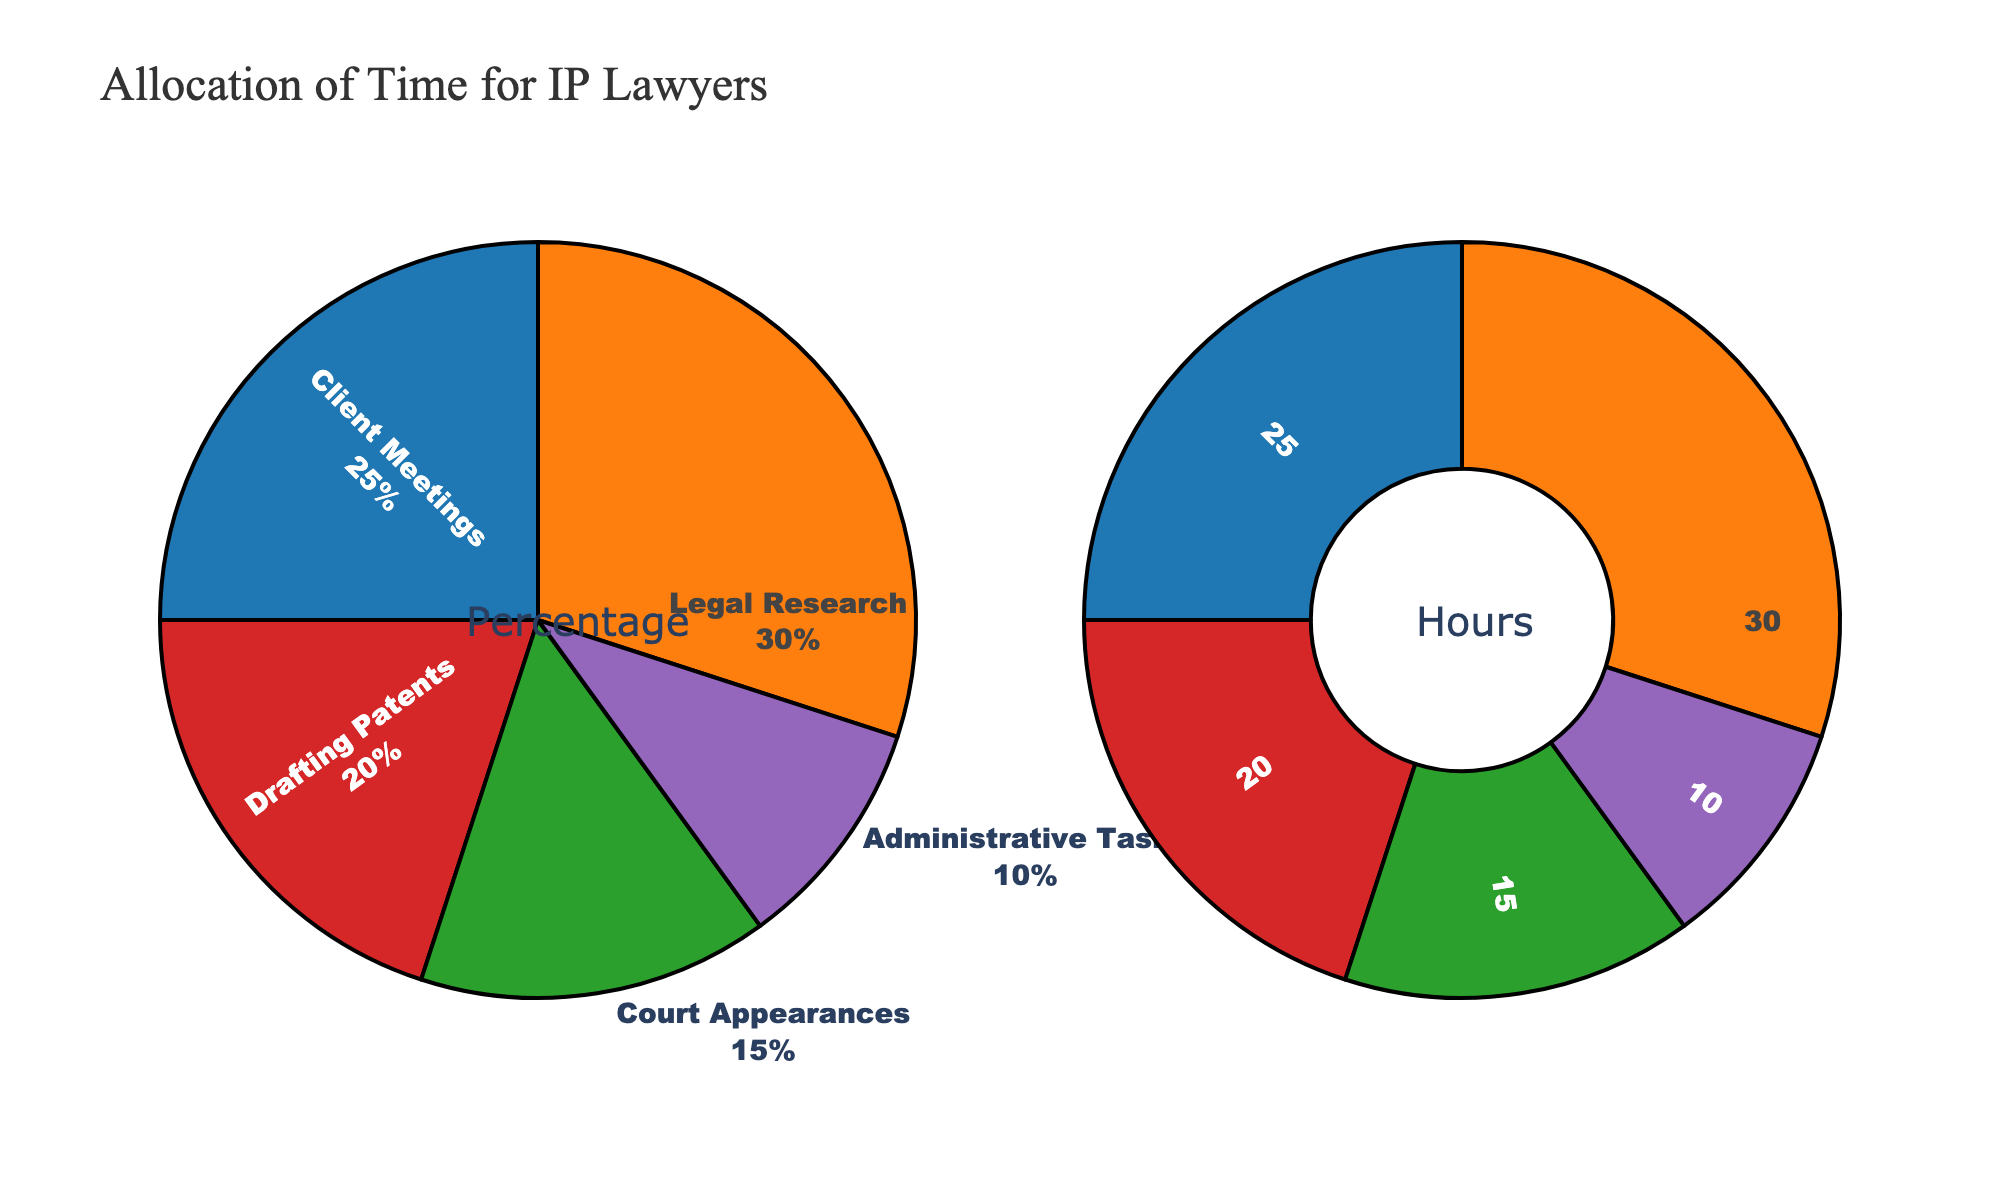What is the title of the figure? The title is usually positioned at the top of the figure. In this case, it is mentioned in the code that the title is 'Arctic Ecosystem Dynamics: Interrelationships Among Key Factors'.
Answer: Arctic Ecosystem Dynamics: Interrelationships Among Key Factors Which axes values represent the 'Polar_Bear_Population'? The 'Polar_Bear_Population' values can be found across the respective row and column in the scatterplot matrix based on their axis titles.
Answer: 25000, 24000, 22500, 21000, 19500, 18000 Which year had the lowest sea ice extent? By looking at the scatter plots and the year-based color scale, the year with the smallest value on the x-axis for 'Sea Ice Extent (km2)' would show the lowest extent. Based on the data provided, 2025 has the lowest value for sea ice extent.
Answer: 2025 How does the Orca sightings trend compare to the trend in Beluga Whale population over the years? By comparing the scatter points on the plots of 'Orca Sightings' vs 'Year' and 'Beluga Whale Population' vs 'Year', we can see if they are increasing or decreasing. The 'Orca Sightings' increase while 'Beluga Whale Population' shows a decreasing trend.
Answer: Orca Sightings are increasing, Beluga Whale population is decreasing What relationship exists between Sea Ice Extent and Polar Bear Population? Observing the scatter plot where 'Sea Ice Extent (km2)' is on the x-axis and 'Polar_Bear_Population' is on the y-axis, we determine if there is a trend. As sea ice extent decreases, polar bear population also decreases.
Answer: Both Sea Ice Extent and Polar Bear Population decrease What is the average Ringed Seal Population value from 2000 to 2025? Summing the Ringed Seal Population values and dividing by the number of values: (4000000 + 3800000 + 3600000 + 3300000 + 3000000 + 2700000) / 6 = 6733333.33.
Answer: 3400000 In which relationship plot is the correlation strongest: 'Sea Ice Extent vs Polar Bear Population' or 'Sea Ice Extent vs Orca Sightings'? By observing the respective scatter plots, stronger correlation typically shows more aligned points along a trend. 'Sea Ice Extent vs Polar Bear Population' shows a stronger negative correlation (points forming a clearer decreasing line).
Answer: Sea Ice Extent vs Polar Bear Population What trend do we observe with Arctic Fox Population relative to Sea Ice Extent over the years? Observing the scatter plot matrix for these variables, we notice a decreasing Arctic Fox Population with decreasing Sea Ice Extent over years.
Answer: Both population and ice extent decrease over time How does the color scale help in interpreting data trends over the years? The color scale represents the year, allowing visual tracking of temporal trends across different scatter plots. This shows trends like decreasing populations or increasing sightings with changing colors.
Answer: Shows trends over the years (temporal tracking) Is there any visible outlier in the Orca Sightings data? Observing the histogram or scatter plots involving Orca Sightings, significant deviations from other data points signify outliers. There's a sharp increase visible in 2025 compared to other years.
Answer: 2025 